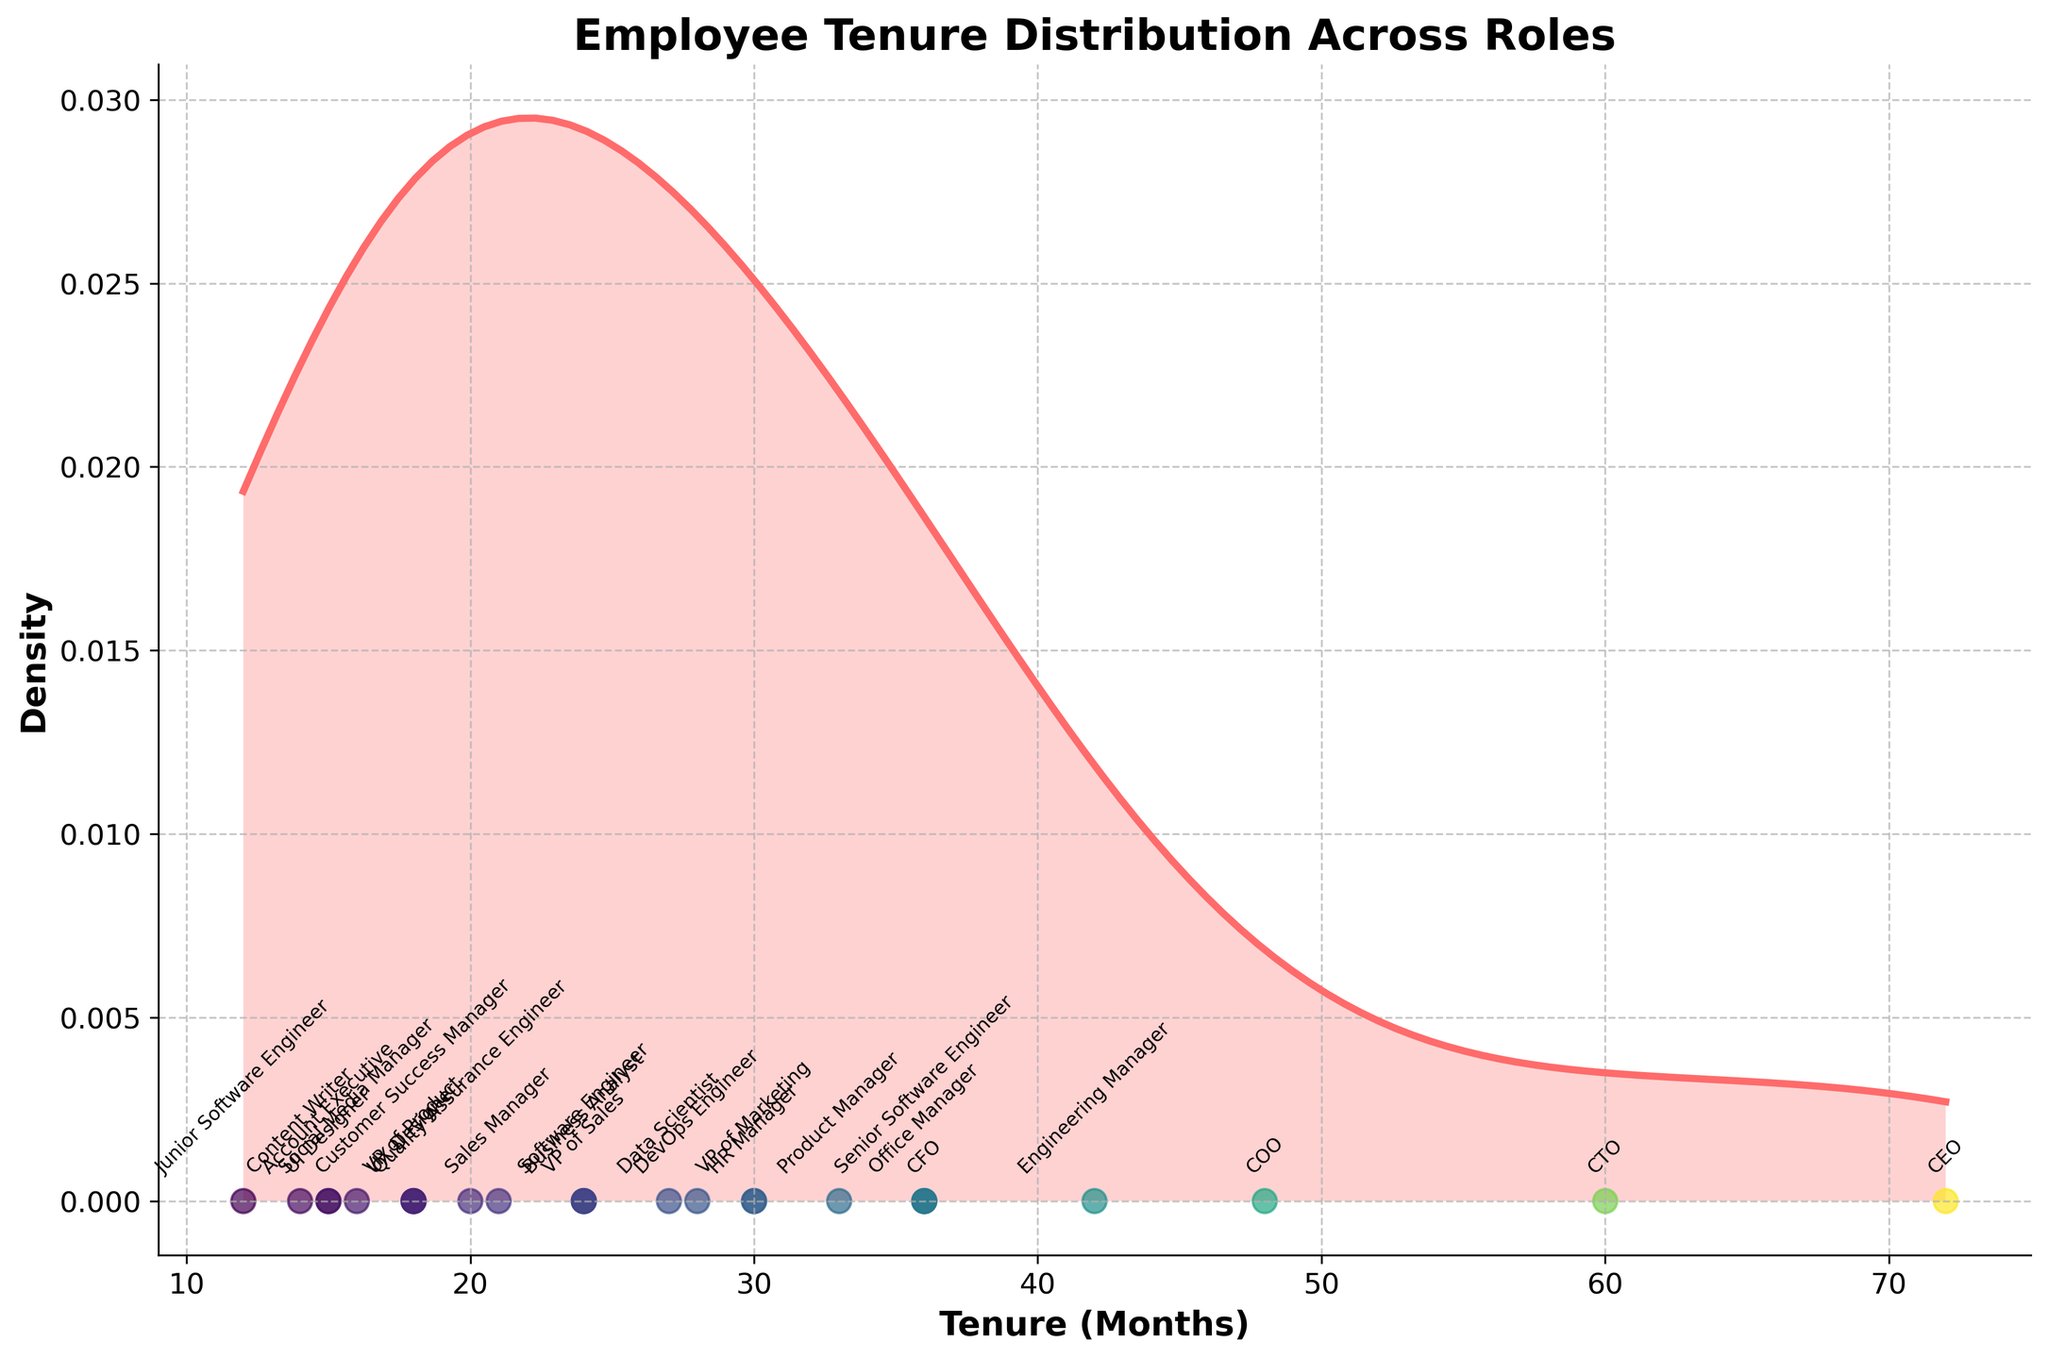what’s the title of the plot? The title is displayed at the top of the plot, which provides a summary of what the plot is about. By looking at the top of the plot, we can see the title.
Answer: Employee Tenure Distribution Across Roles what does the x-axis represent? The x-axis is labeled and tells us the quantity it measures. From the plot, we can see that the x-axis is labeled “Tenure (Months)”.
Answer: Tenure (Months) how many different roles are displayed in the plot? By counting the number of unique labels along the x-axis where data points are scattered, we can determine the number of different roles. Each role has a unique label at the bottom of the plot.
Answer: 24 which role has the longest tenure? The longest tenure can be identified by finding the label corresponding to the data point farthest to the right on the x-axis. From the figure, this point is labeled as "CEO".
Answer: CEO how is the density distribution skewed? The skewness of the density plot can be observed by the distribution pattern of the data points. If the peak of the density curve is closer to the left and there is a long tail to the right, it indicates right skewness, and vice versa. From the plot, we can observe this pattern.
Answer: Right-skewed which roles have a tenure of 36 months? This requires identifying the labels near the x-axis at the point marked by 36 months. From the plot, the roles around 36 months are labeled as "CFO", "Senior Software Engineer", and "Office Manager".
Answer: CFO, Senior Software Engineer, Office Manager what is the range of tenure months covered in the plot? By checking the minimum and maximum values on the x-axis, we can determine the range of tenure months. The plot ranges from the lowest value (12 months) to the highest value (72 months).
Answer: 12 to 72 months which role has a tenure closest to the median value? By visually inspecting the distribution, the median value of tenure months is approximately in the middle of the x-axis range. The middle value in this plot seems to be around 24-30 months. The closest role to this is identified by checking the nearest label which is "VP of Marketing" at 30 months.
Answer: VP of Marketing which role has a tenure closest to the mode of the distribution? The mode of the distribution is the value that appears most frequently, which is reflected by the peak of the density curve. By identifying the peak and finding the closest role labeled below, we can determine that around 24 months is likely the mode, and the nearest role is "VP of Sales".
Answer: VP of Sales 